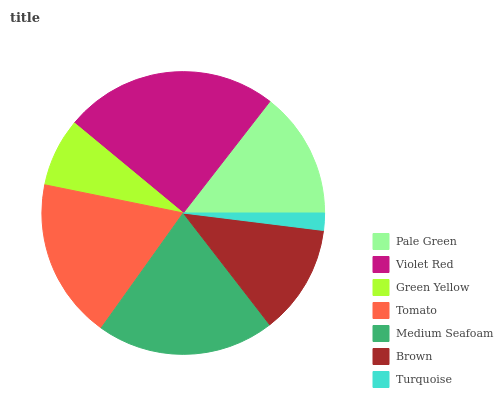Is Turquoise the minimum?
Answer yes or no. Yes. Is Violet Red the maximum?
Answer yes or no. Yes. Is Green Yellow the minimum?
Answer yes or no. No. Is Green Yellow the maximum?
Answer yes or no. No. Is Violet Red greater than Green Yellow?
Answer yes or no. Yes. Is Green Yellow less than Violet Red?
Answer yes or no. Yes. Is Green Yellow greater than Violet Red?
Answer yes or no. No. Is Violet Red less than Green Yellow?
Answer yes or no. No. Is Pale Green the high median?
Answer yes or no. Yes. Is Pale Green the low median?
Answer yes or no. Yes. Is Tomato the high median?
Answer yes or no. No. Is Green Yellow the low median?
Answer yes or no. No. 